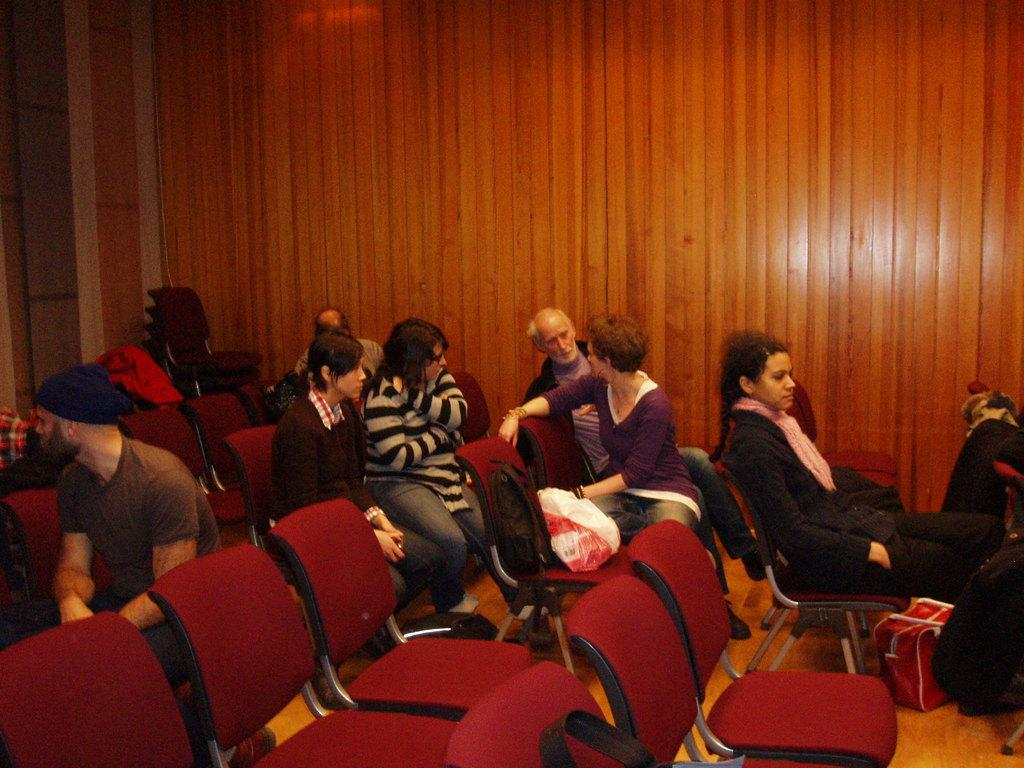What are the people in the image doing? The people in the image are sitting on chairs. What can be seen on the floor in the image? There is a bag on the floor in the image. Where is the other bag located? The other bag is on a chair in the image. What type of wall is visible in the background of the image? There is a wooden wall in the background of the image. How many docks are visible in the image? There are no docks present in the image. What type of mass is being calculated in the image? There is no indication of any mass calculation or related activity in the image. 